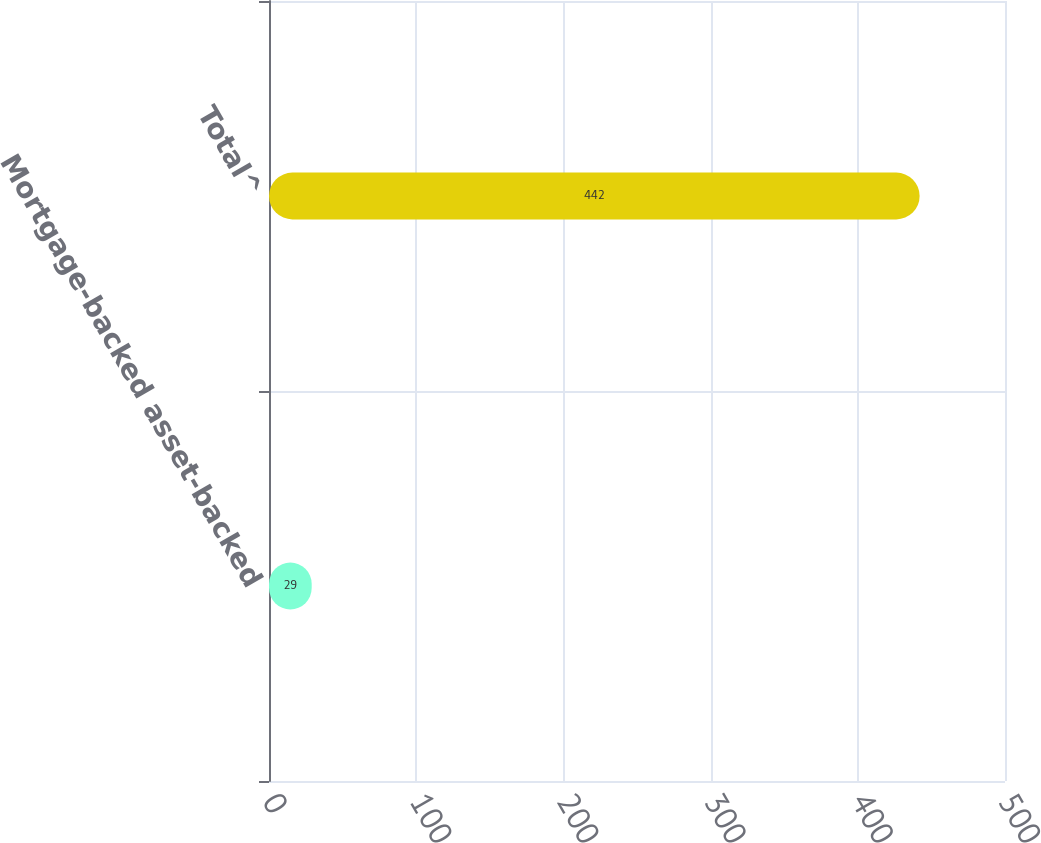Convert chart to OTSL. <chart><loc_0><loc_0><loc_500><loc_500><bar_chart><fcel>Mortgage-backed asset-backed<fcel>Total^<nl><fcel>29<fcel>442<nl></chart> 